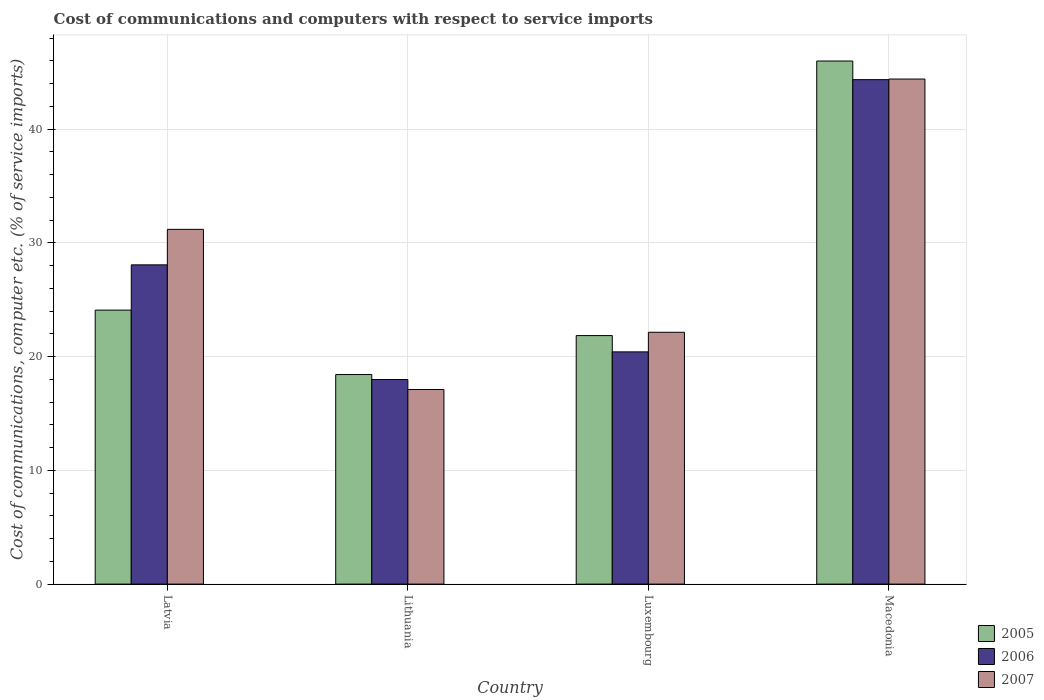How many different coloured bars are there?
Make the answer very short. 3. How many groups of bars are there?
Ensure brevity in your answer.  4. Are the number of bars on each tick of the X-axis equal?
Your response must be concise. Yes. How many bars are there on the 4th tick from the left?
Provide a short and direct response. 3. What is the label of the 4th group of bars from the left?
Your answer should be compact. Macedonia. What is the cost of communications and computers in 2007 in Luxembourg?
Make the answer very short. 22.14. Across all countries, what is the maximum cost of communications and computers in 2006?
Keep it short and to the point. 44.35. Across all countries, what is the minimum cost of communications and computers in 2006?
Give a very brief answer. 17.99. In which country was the cost of communications and computers in 2005 maximum?
Provide a succinct answer. Macedonia. In which country was the cost of communications and computers in 2005 minimum?
Your answer should be compact. Lithuania. What is the total cost of communications and computers in 2005 in the graph?
Offer a very short reply. 110.36. What is the difference between the cost of communications and computers in 2007 in Latvia and that in Lithuania?
Offer a very short reply. 14.08. What is the difference between the cost of communications and computers in 2005 in Macedonia and the cost of communications and computers in 2007 in Latvia?
Offer a terse response. 14.8. What is the average cost of communications and computers in 2006 per country?
Your answer should be compact. 27.71. What is the difference between the cost of communications and computers of/in 2007 and cost of communications and computers of/in 2006 in Latvia?
Your response must be concise. 3.12. In how many countries, is the cost of communications and computers in 2005 greater than 12 %?
Your response must be concise. 4. What is the ratio of the cost of communications and computers in 2006 in Latvia to that in Luxembourg?
Your answer should be very brief. 1.37. Is the cost of communications and computers in 2007 in Latvia less than that in Macedonia?
Your answer should be compact. Yes. Is the difference between the cost of communications and computers in 2007 in Latvia and Lithuania greater than the difference between the cost of communications and computers in 2006 in Latvia and Lithuania?
Keep it short and to the point. Yes. What is the difference between the highest and the second highest cost of communications and computers in 2005?
Make the answer very short. 2.24. What is the difference between the highest and the lowest cost of communications and computers in 2006?
Ensure brevity in your answer.  26.37. In how many countries, is the cost of communications and computers in 2005 greater than the average cost of communications and computers in 2005 taken over all countries?
Provide a succinct answer. 1. Is the sum of the cost of communications and computers in 2006 in Latvia and Lithuania greater than the maximum cost of communications and computers in 2007 across all countries?
Give a very brief answer. Yes. What does the 3rd bar from the right in Macedonia represents?
Keep it short and to the point. 2005. How many bars are there?
Offer a very short reply. 12. Are all the bars in the graph horizontal?
Offer a terse response. No. What is the difference between two consecutive major ticks on the Y-axis?
Offer a very short reply. 10. Does the graph contain grids?
Ensure brevity in your answer.  Yes. Where does the legend appear in the graph?
Offer a terse response. Bottom right. How many legend labels are there?
Keep it short and to the point. 3. What is the title of the graph?
Provide a succinct answer. Cost of communications and computers with respect to service imports. Does "2006" appear as one of the legend labels in the graph?
Provide a succinct answer. Yes. What is the label or title of the Y-axis?
Your response must be concise. Cost of communications, computer etc. (% of service imports). What is the Cost of communications, computer etc. (% of service imports) in 2005 in Latvia?
Your answer should be compact. 24.09. What is the Cost of communications, computer etc. (% of service imports) of 2006 in Latvia?
Give a very brief answer. 28.07. What is the Cost of communications, computer etc. (% of service imports) of 2007 in Latvia?
Your answer should be very brief. 31.19. What is the Cost of communications, computer etc. (% of service imports) in 2005 in Lithuania?
Give a very brief answer. 18.43. What is the Cost of communications, computer etc. (% of service imports) of 2006 in Lithuania?
Ensure brevity in your answer.  17.99. What is the Cost of communications, computer etc. (% of service imports) of 2007 in Lithuania?
Your answer should be compact. 17.11. What is the Cost of communications, computer etc. (% of service imports) of 2005 in Luxembourg?
Provide a succinct answer. 21.85. What is the Cost of communications, computer etc. (% of service imports) in 2006 in Luxembourg?
Make the answer very short. 20.42. What is the Cost of communications, computer etc. (% of service imports) in 2007 in Luxembourg?
Ensure brevity in your answer.  22.14. What is the Cost of communications, computer etc. (% of service imports) of 2005 in Macedonia?
Your answer should be very brief. 45.99. What is the Cost of communications, computer etc. (% of service imports) in 2006 in Macedonia?
Offer a very short reply. 44.35. What is the Cost of communications, computer etc. (% of service imports) in 2007 in Macedonia?
Your answer should be compact. 44.41. Across all countries, what is the maximum Cost of communications, computer etc. (% of service imports) in 2005?
Your answer should be compact. 45.99. Across all countries, what is the maximum Cost of communications, computer etc. (% of service imports) in 2006?
Provide a short and direct response. 44.35. Across all countries, what is the maximum Cost of communications, computer etc. (% of service imports) in 2007?
Keep it short and to the point. 44.41. Across all countries, what is the minimum Cost of communications, computer etc. (% of service imports) of 2005?
Provide a succinct answer. 18.43. Across all countries, what is the minimum Cost of communications, computer etc. (% of service imports) of 2006?
Your response must be concise. 17.99. Across all countries, what is the minimum Cost of communications, computer etc. (% of service imports) of 2007?
Ensure brevity in your answer.  17.11. What is the total Cost of communications, computer etc. (% of service imports) of 2005 in the graph?
Your answer should be very brief. 110.36. What is the total Cost of communications, computer etc. (% of service imports) in 2006 in the graph?
Offer a terse response. 110.83. What is the total Cost of communications, computer etc. (% of service imports) in 2007 in the graph?
Give a very brief answer. 114.85. What is the difference between the Cost of communications, computer etc. (% of service imports) of 2005 in Latvia and that in Lithuania?
Ensure brevity in your answer.  5.66. What is the difference between the Cost of communications, computer etc. (% of service imports) in 2006 in Latvia and that in Lithuania?
Your answer should be very brief. 10.08. What is the difference between the Cost of communications, computer etc. (% of service imports) of 2007 in Latvia and that in Lithuania?
Ensure brevity in your answer.  14.08. What is the difference between the Cost of communications, computer etc. (% of service imports) in 2005 in Latvia and that in Luxembourg?
Make the answer very short. 2.24. What is the difference between the Cost of communications, computer etc. (% of service imports) of 2006 in Latvia and that in Luxembourg?
Keep it short and to the point. 7.65. What is the difference between the Cost of communications, computer etc. (% of service imports) in 2007 in Latvia and that in Luxembourg?
Keep it short and to the point. 9.05. What is the difference between the Cost of communications, computer etc. (% of service imports) of 2005 in Latvia and that in Macedonia?
Keep it short and to the point. -21.9. What is the difference between the Cost of communications, computer etc. (% of service imports) in 2006 in Latvia and that in Macedonia?
Offer a very short reply. -16.28. What is the difference between the Cost of communications, computer etc. (% of service imports) in 2007 in Latvia and that in Macedonia?
Keep it short and to the point. -13.22. What is the difference between the Cost of communications, computer etc. (% of service imports) of 2005 in Lithuania and that in Luxembourg?
Provide a succinct answer. -3.42. What is the difference between the Cost of communications, computer etc. (% of service imports) in 2006 in Lithuania and that in Luxembourg?
Keep it short and to the point. -2.43. What is the difference between the Cost of communications, computer etc. (% of service imports) in 2007 in Lithuania and that in Luxembourg?
Your answer should be very brief. -5.03. What is the difference between the Cost of communications, computer etc. (% of service imports) of 2005 in Lithuania and that in Macedonia?
Your response must be concise. -27.57. What is the difference between the Cost of communications, computer etc. (% of service imports) of 2006 in Lithuania and that in Macedonia?
Your answer should be compact. -26.37. What is the difference between the Cost of communications, computer etc. (% of service imports) in 2007 in Lithuania and that in Macedonia?
Your answer should be compact. -27.3. What is the difference between the Cost of communications, computer etc. (% of service imports) in 2005 in Luxembourg and that in Macedonia?
Your answer should be compact. -24.14. What is the difference between the Cost of communications, computer etc. (% of service imports) of 2006 in Luxembourg and that in Macedonia?
Provide a short and direct response. -23.93. What is the difference between the Cost of communications, computer etc. (% of service imports) in 2007 in Luxembourg and that in Macedonia?
Give a very brief answer. -22.27. What is the difference between the Cost of communications, computer etc. (% of service imports) of 2005 in Latvia and the Cost of communications, computer etc. (% of service imports) of 2006 in Lithuania?
Keep it short and to the point. 6.1. What is the difference between the Cost of communications, computer etc. (% of service imports) in 2005 in Latvia and the Cost of communications, computer etc. (% of service imports) in 2007 in Lithuania?
Keep it short and to the point. 6.98. What is the difference between the Cost of communications, computer etc. (% of service imports) of 2006 in Latvia and the Cost of communications, computer etc. (% of service imports) of 2007 in Lithuania?
Provide a succinct answer. 10.96. What is the difference between the Cost of communications, computer etc. (% of service imports) in 2005 in Latvia and the Cost of communications, computer etc. (% of service imports) in 2006 in Luxembourg?
Offer a terse response. 3.67. What is the difference between the Cost of communications, computer etc. (% of service imports) in 2005 in Latvia and the Cost of communications, computer etc. (% of service imports) in 2007 in Luxembourg?
Offer a terse response. 1.95. What is the difference between the Cost of communications, computer etc. (% of service imports) of 2006 in Latvia and the Cost of communications, computer etc. (% of service imports) of 2007 in Luxembourg?
Your response must be concise. 5.93. What is the difference between the Cost of communications, computer etc. (% of service imports) of 2005 in Latvia and the Cost of communications, computer etc. (% of service imports) of 2006 in Macedonia?
Offer a very short reply. -20.26. What is the difference between the Cost of communications, computer etc. (% of service imports) of 2005 in Latvia and the Cost of communications, computer etc. (% of service imports) of 2007 in Macedonia?
Your answer should be very brief. -20.32. What is the difference between the Cost of communications, computer etc. (% of service imports) of 2006 in Latvia and the Cost of communications, computer etc. (% of service imports) of 2007 in Macedonia?
Make the answer very short. -16.34. What is the difference between the Cost of communications, computer etc. (% of service imports) in 2005 in Lithuania and the Cost of communications, computer etc. (% of service imports) in 2006 in Luxembourg?
Provide a short and direct response. -1.99. What is the difference between the Cost of communications, computer etc. (% of service imports) of 2005 in Lithuania and the Cost of communications, computer etc. (% of service imports) of 2007 in Luxembourg?
Give a very brief answer. -3.72. What is the difference between the Cost of communications, computer etc. (% of service imports) of 2006 in Lithuania and the Cost of communications, computer etc. (% of service imports) of 2007 in Luxembourg?
Your response must be concise. -4.15. What is the difference between the Cost of communications, computer etc. (% of service imports) of 2005 in Lithuania and the Cost of communications, computer etc. (% of service imports) of 2006 in Macedonia?
Your response must be concise. -25.93. What is the difference between the Cost of communications, computer etc. (% of service imports) of 2005 in Lithuania and the Cost of communications, computer etc. (% of service imports) of 2007 in Macedonia?
Your answer should be very brief. -25.98. What is the difference between the Cost of communications, computer etc. (% of service imports) of 2006 in Lithuania and the Cost of communications, computer etc. (% of service imports) of 2007 in Macedonia?
Your response must be concise. -26.42. What is the difference between the Cost of communications, computer etc. (% of service imports) in 2005 in Luxembourg and the Cost of communications, computer etc. (% of service imports) in 2006 in Macedonia?
Ensure brevity in your answer.  -22.5. What is the difference between the Cost of communications, computer etc. (% of service imports) of 2005 in Luxembourg and the Cost of communications, computer etc. (% of service imports) of 2007 in Macedonia?
Keep it short and to the point. -22.56. What is the difference between the Cost of communications, computer etc. (% of service imports) in 2006 in Luxembourg and the Cost of communications, computer etc. (% of service imports) in 2007 in Macedonia?
Provide a short and direct response. -23.99. What is the average Cost of communications, computer etc. (% of service imports) in 2005 per country?
Your response must be concise. 27.59. What is the average Cost of communications, computer etc. (% of service imports) of 2006 per country?
Make the answer very short. 27.71. What is the average Cost of communications, computer etc. (% of service imports) of 2007 per country?
Keep it short and to the point. 28.71. What is the difference between the Cost of communications, computer etc. (% of service imports) of 2005 and Cost of communications, computer etc. (% of service imports) of 2006 in Latvia?
Offer a very short reply. -3.98. What is the difference between the Cost of communications, computer etc. (% of service imports) in 2005 and Cost of communications, computer etc. (% of service imports) in 2007 in Latvia?
Offer a very short reply. -7.1. What is the difference between the Cost of communications, computer etc. (% of service imports) of 2006 and Cost of communications, computer etc. (% of service imports) of 2007 in Latvia?
Provide a short and direct response. -3.12. What is the difference between the Cost of communications, computer etc. (% of service imports) in 2005 and Cost of communications, computer etc. (% of service imports) in 2006 in Lithuania?
Give a very brief answer. 0.44. What is the difference between the Cost of communications, computer etc. (% of service imports) of 2005 and Cost of communications, computer etc. (% of service imports) of 2007 in Lithuania?
Your response must be concise. 1.31. What is the difference between the Cost of communications, computer etc. (% of service imports) of 2006 and Cost of communications, computer etc. (% of service imports) of 2007 in Lithuania?
Make the answer very short. 0.88. What is the difference between the Cost of communications, computer etc. (% of service imports) of 2005 and Cost of communications, computer etc. (% of service imports) of 2006 in Luxembourg?
Offer a terse response. 1.43. What is the difference between the Cost of communications, computer etc. (% of service imports) in 2005 and Cost of communications, computer etc. (% of service imports) in 2007 in Luxembourg?
Give a very brief answer. -0.29. What is the difference between the Cost of communications, computer etc. (% of service imports) of 2006 and Cost of communications, computer etc. (% of service imports) of 2007 in Luxembourg?
Your response must be concise. -1.72. What is the difference between the Cost of communications, computer etc. (% of service imports) of 2005 and Cost of communications, computer etc. (% of service imports) of 2006 in Macedonia?
Offer a terse response. 1.64. What is the difference between the Cost of communications, computer etc. (% of service imports) of 2005 and Cost of communications, computer etc. (% of service imports) of 2007 in Macedonia?
Offer a very short reply. 1.58. What is the difference between the Cost of communications, computer etc. (% of service imports) of 2006 and Cost of communications, computer etc. (% of service imports) of 2007 in Macedonia?
Your answer should be very brief. -0.05. What is the ratio of the Cost of communications, computer etc. (% of service imports) of 2005 in Latvia to that in Lithuania?
Your answer should be compact. 1.31. What is the ratio of the Cost of communications, computer etc. (% of service imports) of 2006 in Latvia to that in Lithuania?
Your response must be concise. 1.56. What is the ratio of the Cost of communications, computer etc. (% of service imports) of 2007 in Latvia to that in Lithuania?
Give a very brief answer. 1.82. What is the ratio of the Cost of communications, computer etc. (% of service imports) in 2005 in Latvia to that in Luxembourg?
Your response must be concise. 1.1. What is the ratio of the Cost of communications, computer etc. (% of service imports) in 2006 in Latvia to that in Luxembourg?
Give a very brief answer. 1.37. What is the ratio of the Cost of communications, computer etc. (% of service imports) of 2007 in Latvia to that in Luxembourg?
Your answer should be very brief. 1.41. What is the ratio of the Cost of communications, computer etc. (% of service imports) in 2005 in Latvia to that in Macedonia?
Provide a short and direct response. 0.52. What is the ratio of the Cost of communications, computer etc. (% of service imports) in 2006 in Latvia to that in Macedonia?
Your answer should be very brief. 0.63. What is the ratio of the Cost of communications, computer etc. (% of service imports) in 2007 in Latvia to that in Macedonia?
Your response must be concise. 0.7. What is the ratio of the Cost of communications, computer etc. (% of service imports) in 2005 in Lithuania to that in Luxembourg?
Your answer should be very brief. 0.84. What is the ratio of the Cost of communications, computer etc. (% of service imports) in 2006 in Lithuania to that in Luxembourg?
Provide a short and direct response. 0.88. What is the ratio of the Cost of communications, computer etc. (% of service imports) of 2007 in Lithuania to that in Luxembourg?
Give a very brief answer. 0.77. What is the ratio of the Cost of communications, computer etc. (% of service imports) in 2005 in Lithuania to that in Macedonia?
Give a very brief answer. 0.4. What is the ratio of the Cost of communications, computer etc. (% of service imports) in 2006 in Lithuania to that in Macedonia?
Provide a succinct answer. 0.41. What is the ratio of the Cost of communications, computer etc. (% of service imports) in 2007 in Lithuania to that in Macedonia?
Give a very brief answer. 0.39. What is the ratio of the Cost of communications, computer etc. (% of service imports) of 2005 in Luxembourg to that in Macedonia?
Keep it short and to the point. 0.48. What is the ratio of the Cost of communications, computer etc. (% of service imports) in 2006 in Luxembourg to that in Macedonia?
Your answer should be very brief. 0.46. What is the ratio of the Cost of communications, computer etc. (% of service imports) of 2007 in Luxembourg to that in Macedonia?
Provide a short and direct response. 0.5. What is the difference between the highest and the second highest Cost of communications, computer etc. (% of service imports) in 2005?
Your response must be concise. 21.9. What is the difference between the highest and the second highest Cost of communications, computer etc. (% of service imports) of 2006?
Your answer should be compact. 16.28. What is the difference between the highest and the second highest Cost of communications, computer etc. (% of service imports) in 2007?
Ensure brevity in your answer.  13.22. What is the difference between the highest and the lowest Cost of communications, computer etc. (% of service imports) of 2005?
Offer a very short reply. 27.57. What is the difference between the highest and the lowest Cost of communications, computer etc. (% of service imports) of 2006?
Provide a short and direct response. 26.37. What is the difference between the highest and the lowest Cost of communications, computer etc. (% of service imports) of 2007?
Offer a terse response. 27.3. 